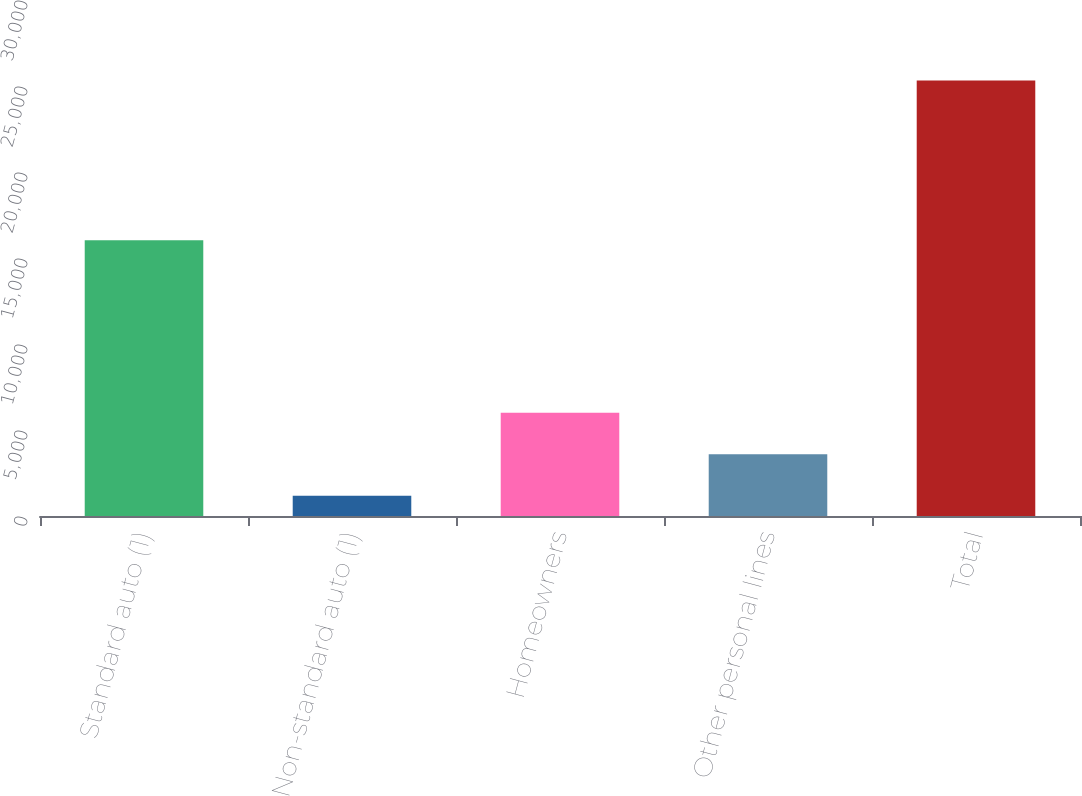<chart> <loc_0><loc_0><loc_500><loc_500><bar_chart><fcel>Standard auto (1)<fcel>Non-standard auto (1)<fcel>Homeowners<fcel>Other personal lines<fcel>Total<nl><fcel>16035<fcel>1179<fcel>6007.6<fcel>3593.3<fcel>25322<nl></chart> 